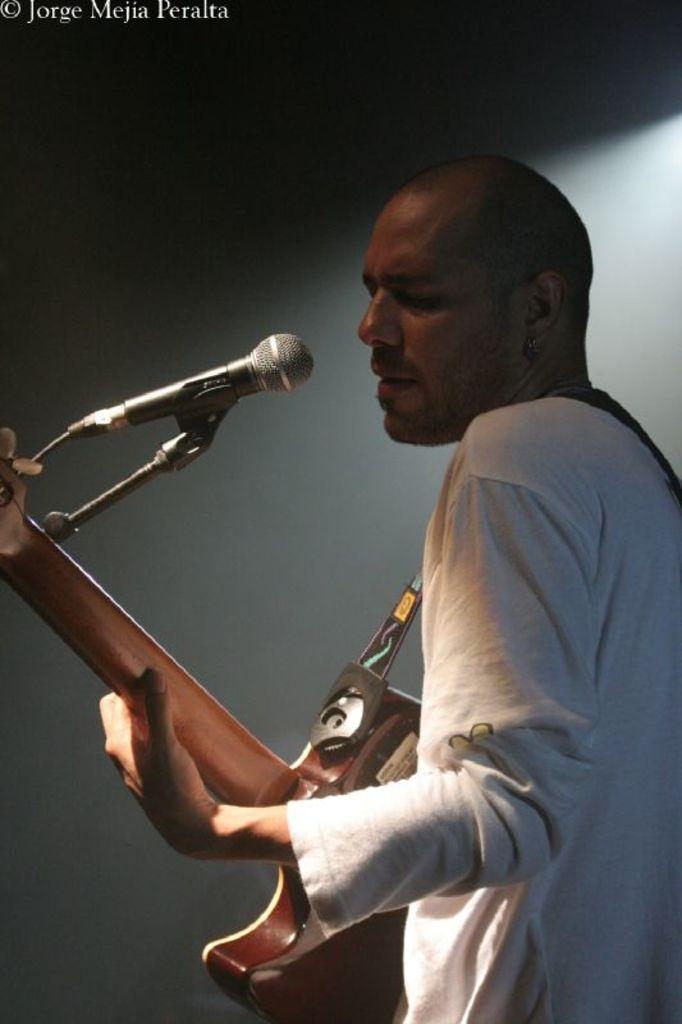What is the main subject of the image? There is a person in the image. What is the person doing in the image? The person is playing a guitar. What other equipment is visible in the image? There is a microphone with a mic stand in the image. Can you describe any additional features of the image? There is a watermark at the top of the image. How many girls are smiling in the image? There are no girls present in the image, nor is anyone smiling. 